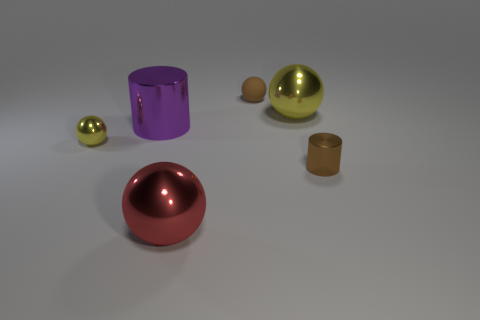Add 3 tiny cyan rubber cubes. How many objects exist? 9 Subtract all brown balls. How many balls are left? 3 Subtract all tiny metallic spheres. How many spheres are left? 3 Subtract all cylinders. How many objects are left? 4 Subtract all big purple matte cylinders. Subtract all yellow spheres. How many objects are left? 4 Add 4 balls. How many balls are left? 8 Add 6 yellow spheres. How many yellow spheres exist? 8 Subtract 0 yellow cubes. How many objects are left? 6 Subtract all yellow spheres. Subtract all brown cylinders. How many spheres are left? 2 Subtract all cyan cubes. How many yellow spheres are left? 2 